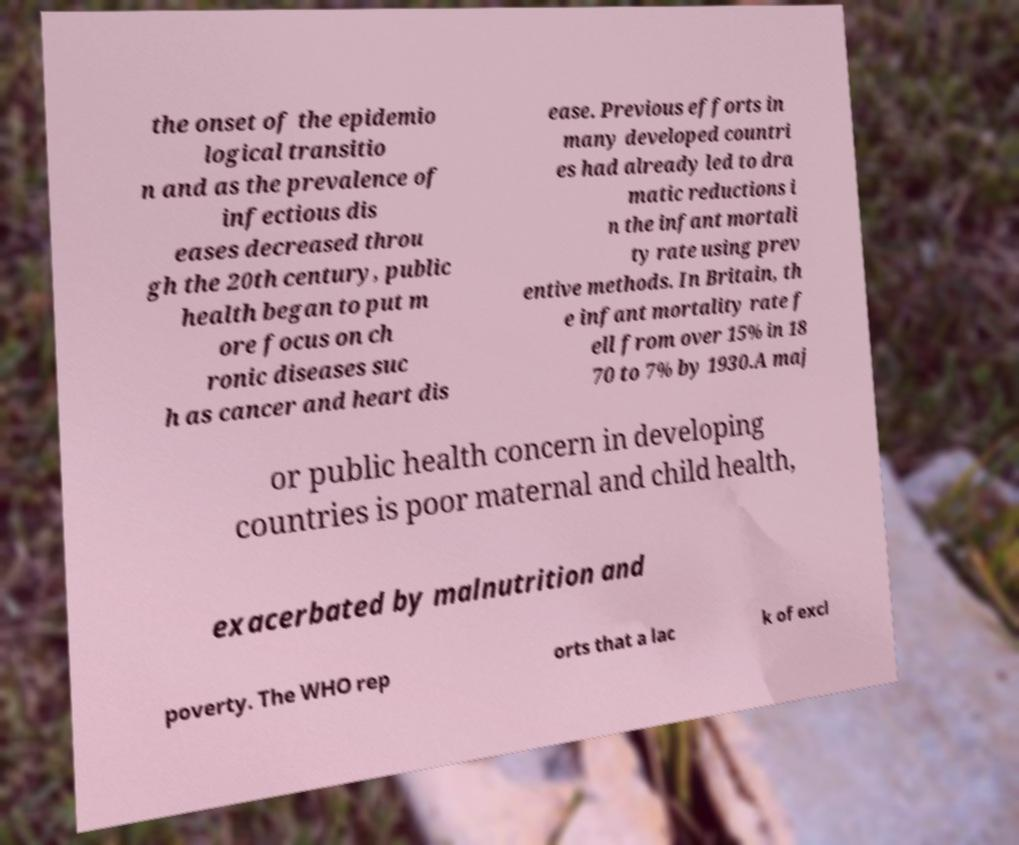Please identify and transcribe the text found in this image. the onset of the epidemio logical transitio n and as the prevalence of infectious dis eases decreased throu gh the 20th century, public health began to put m ore focus on ch ronic diseases suc h as cancer and heart dis ease. Previous efforts in many developed countri es had already led to dra matic reductions i n the infant mortali ty rate using prev entive methods. In Britain, th e infant mortality rate f ell from over 15% in 18 70 to 7% by 1930.A maj or public health concern in developing countries is poor maternal and child health, exacerbated by malnutrition and poverty. The WHO rep orts that a lac k of excl 